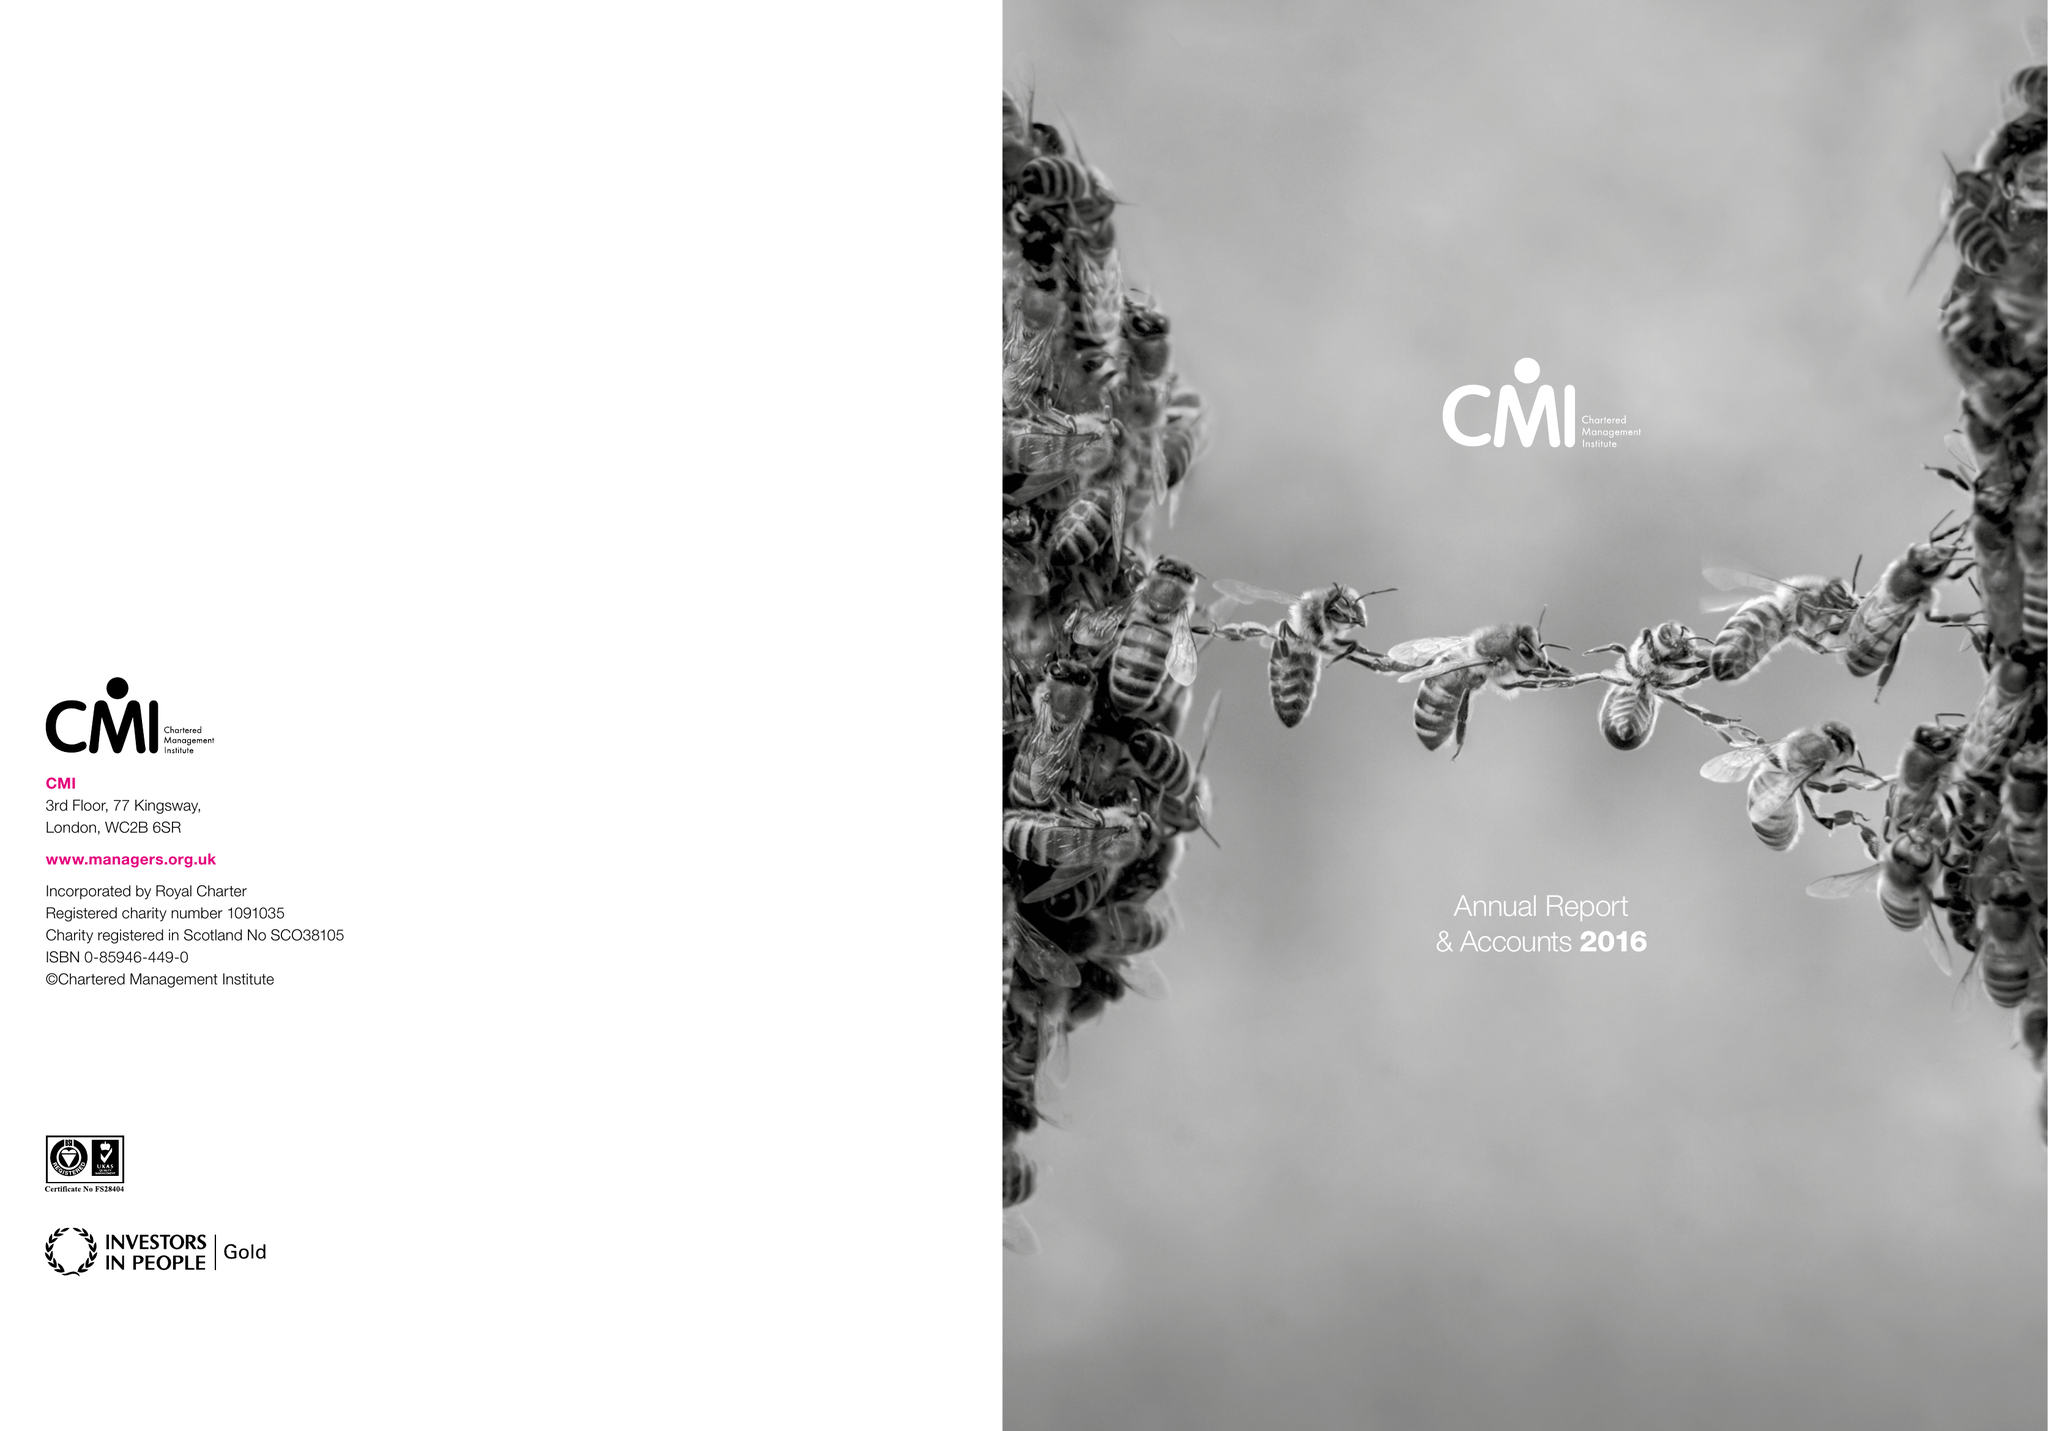What is the value for the report_date?
Answer the question using a single word or phrase. 2016-03-31 